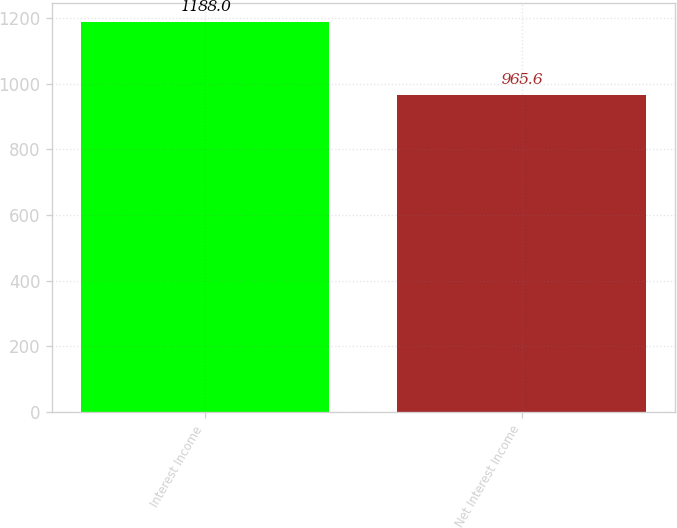Convert chart. <chart><loc_0><loc_0><loc_500><loc_500><bar_chart><fcel>Interest Income<fcel>Net Interest Income<nl><fcel>1188<fcel>965.6<nl></chart> 